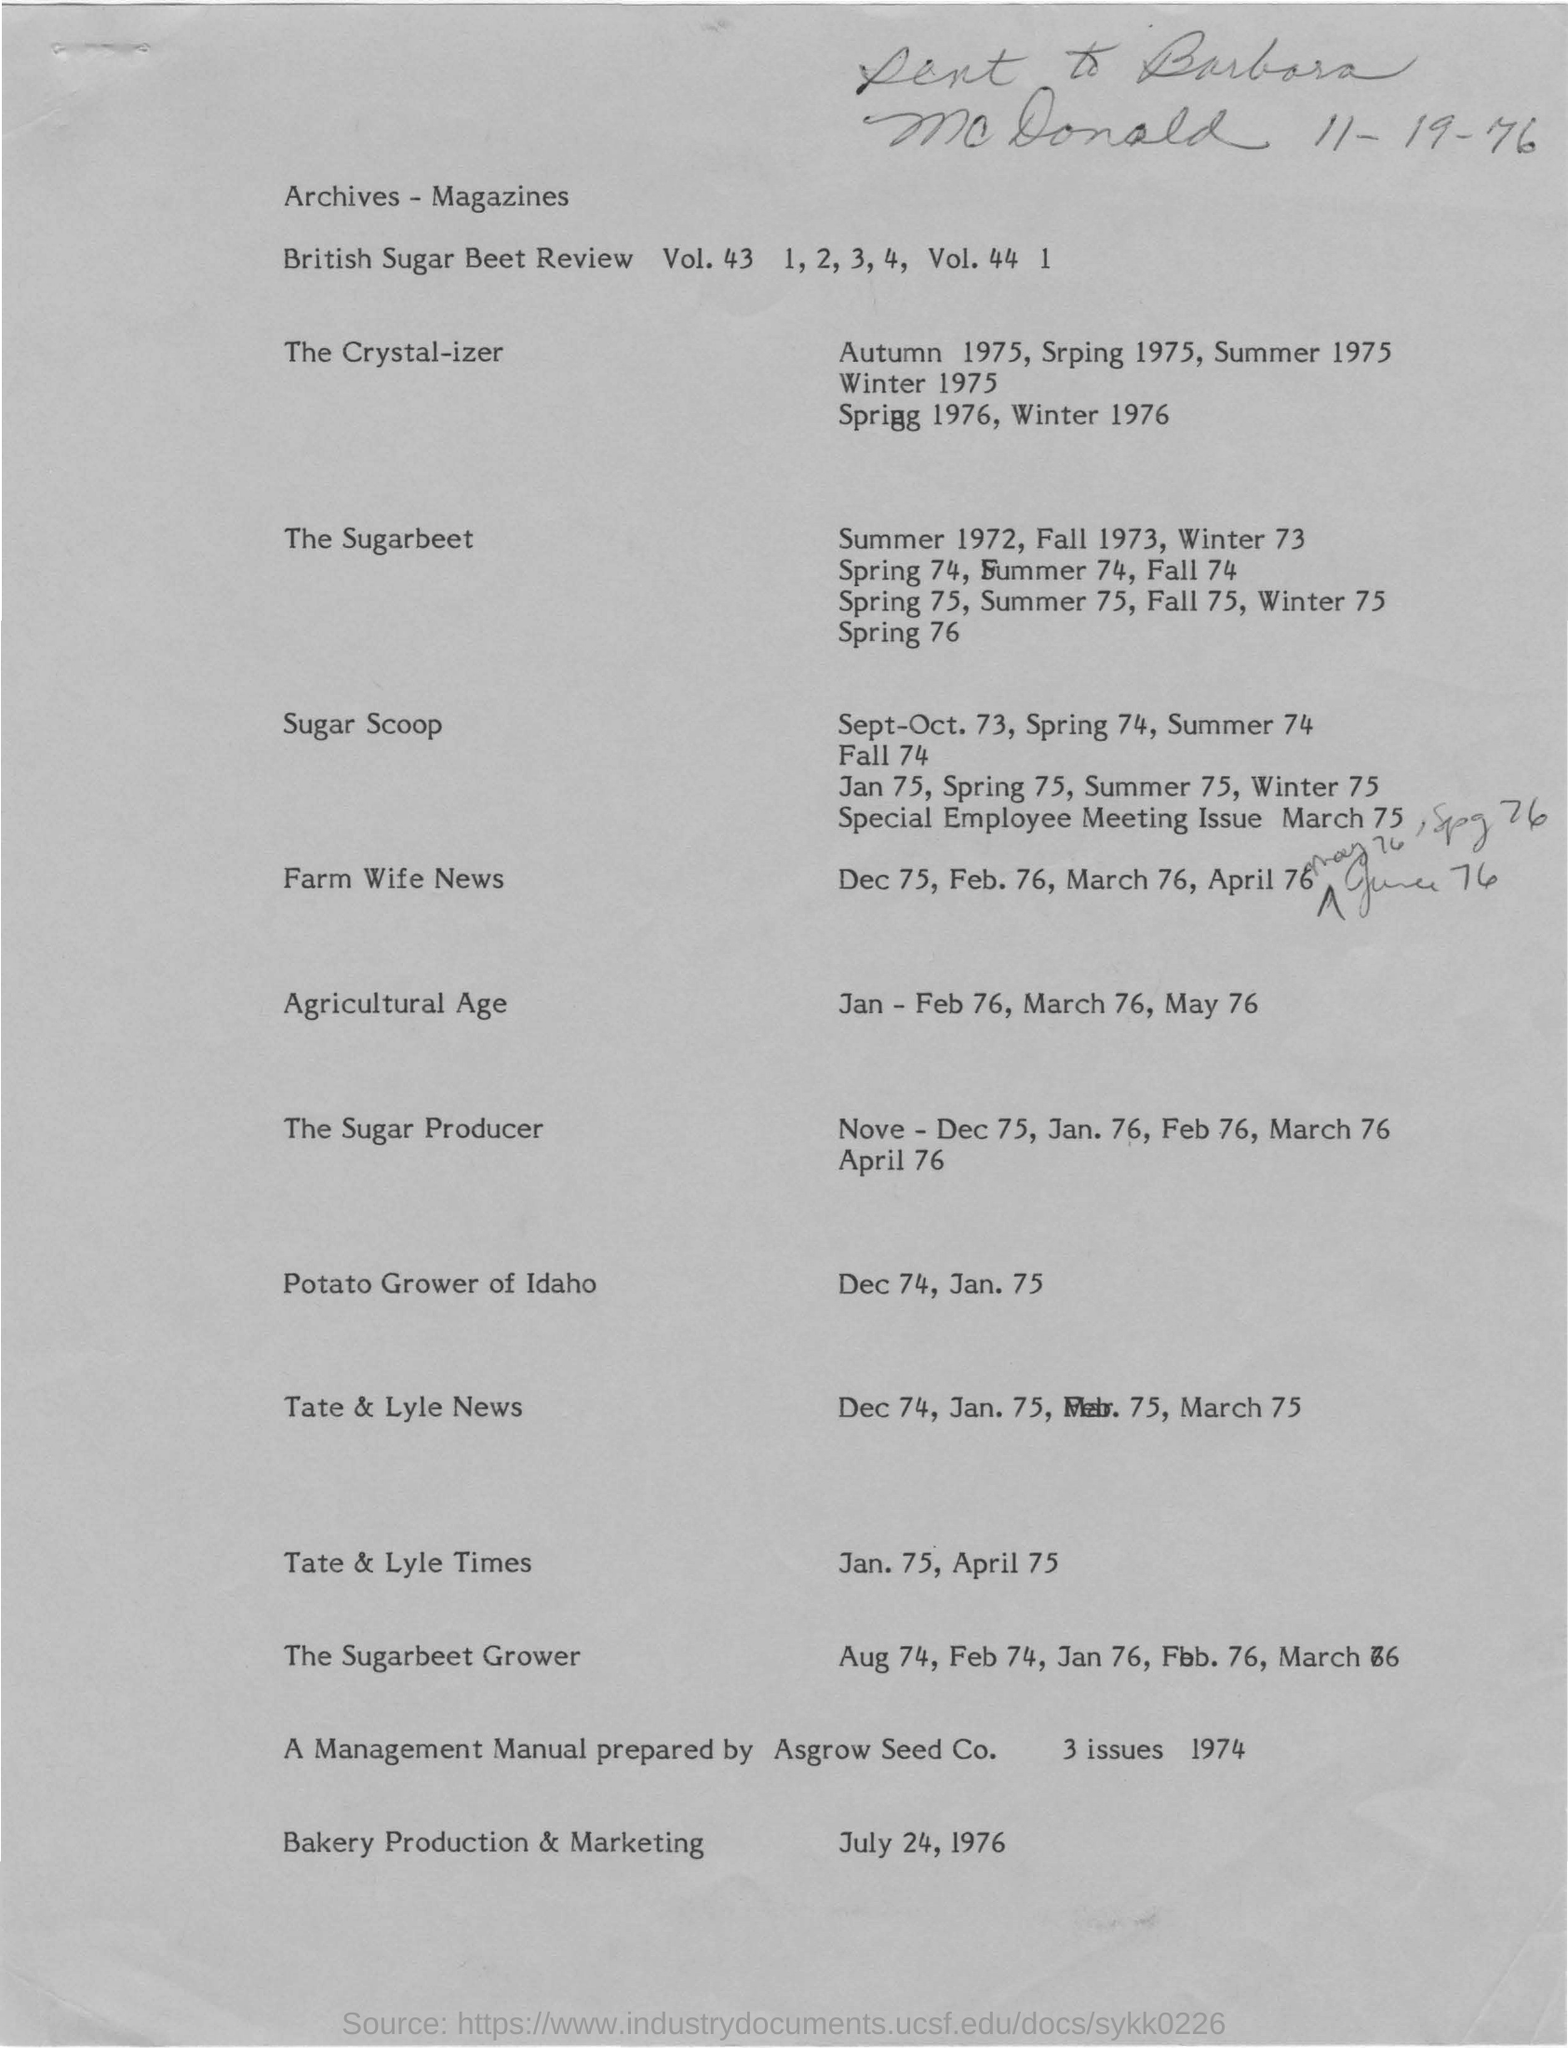What is the date mentioned at the top of the document?
Give a very brief answer. 11- 19- 76. What is the Agricultural Age mentioned in the document?
Keep it short and to the point. Jan - Feb 76, March 76, May 76. 